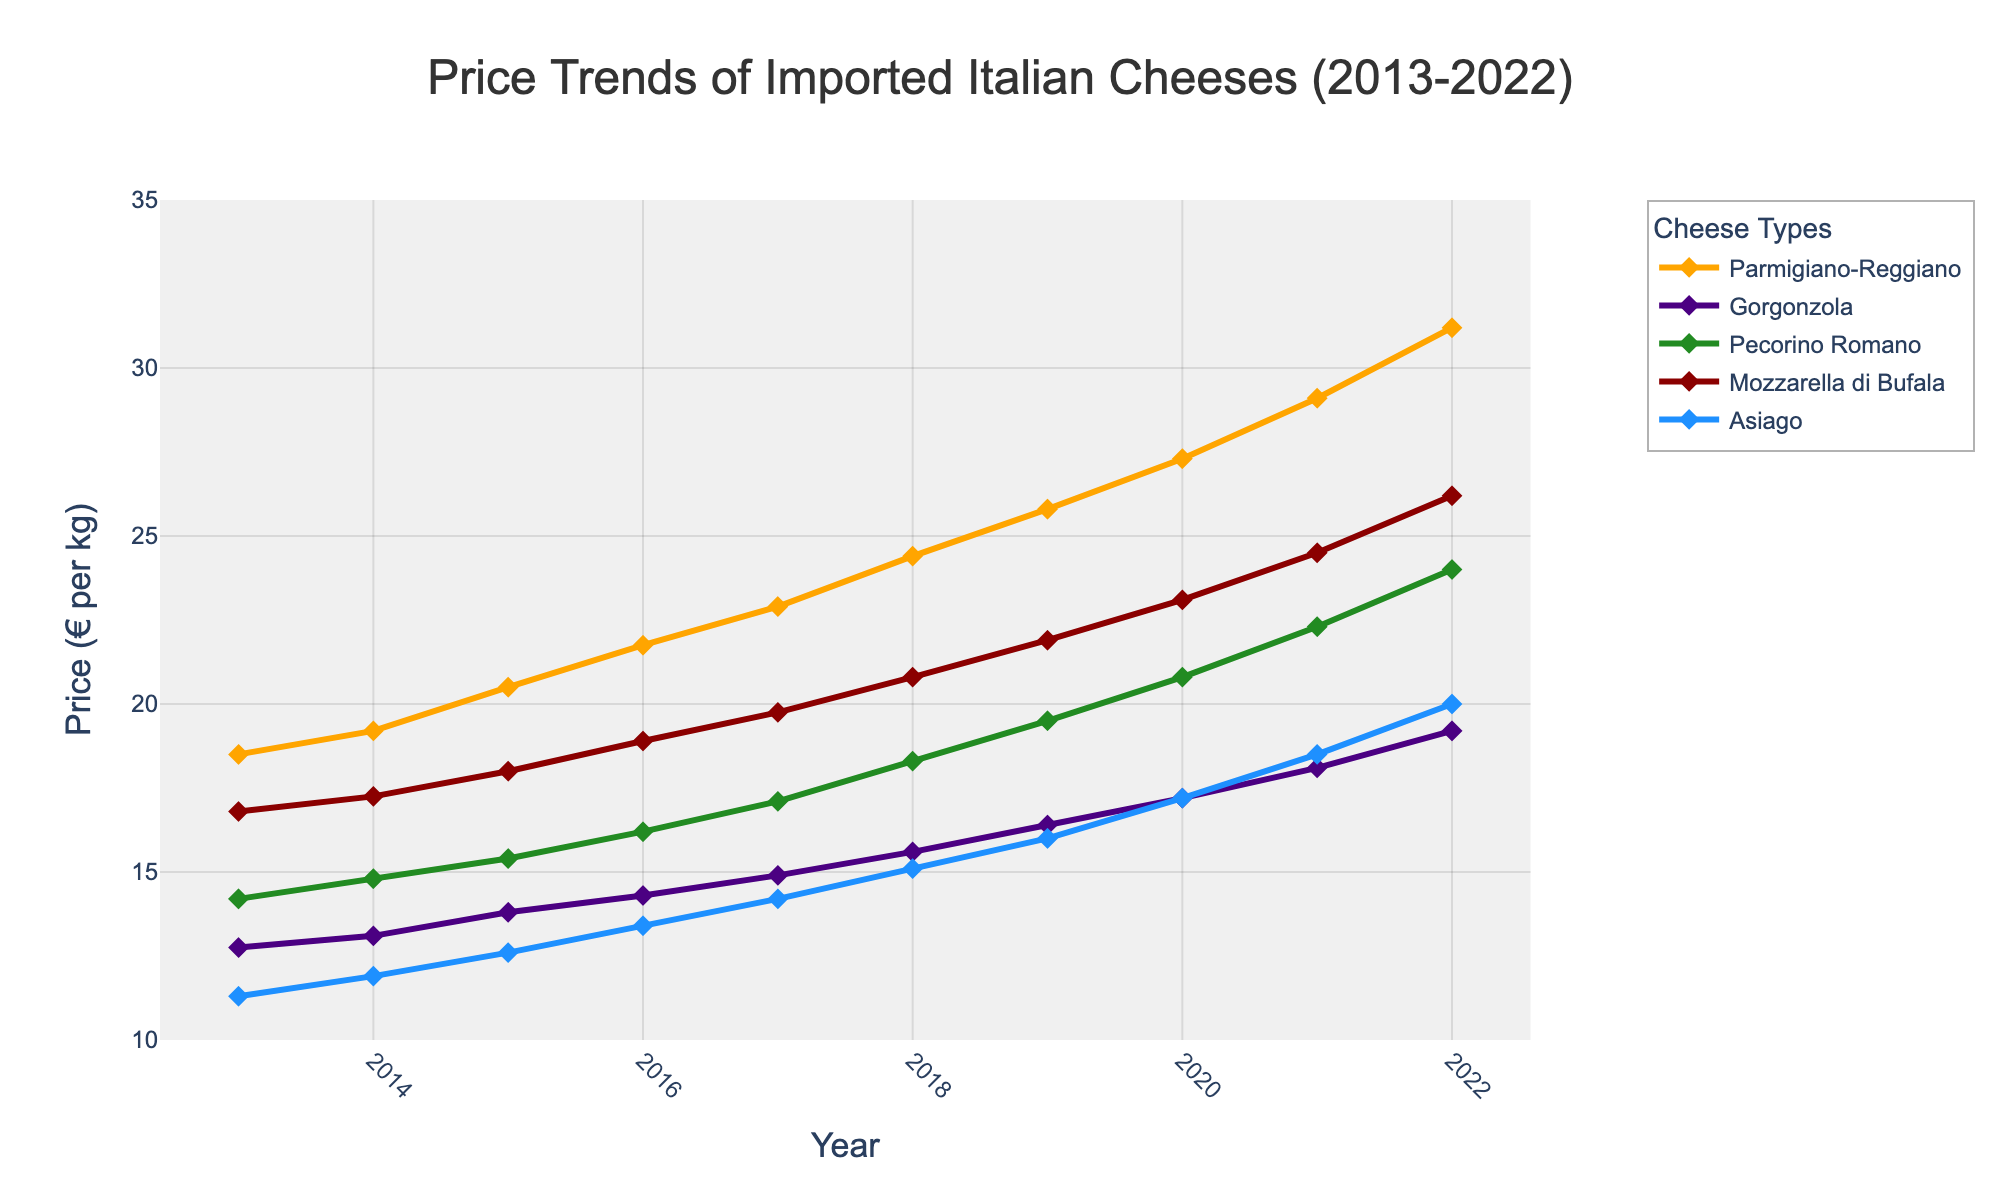What is the trend of Parmigiano-Reggiano prices from 2013 to 2022? The line for Parmigiano-Reggiano shows a consistent upward trend throughout the decade, starting at 18.50€ in 2013 and reaching 31.20€ in 2022.
Answer: Prices consistently increased Which cheese had the highest price in 2022, and what was it? By looking at the 2022 data points, Parmigiano-Reggiano had the highest price among the cheeses, with a price of 31.20€.
Answer: Parmigiano-Reggiano at 31.20€ How much did the price of Mozzarella di Bufala increase from 2013 to 2022? Subtract the 2013 price (16.80€) from the 2022 price (26.20€) to find the increase. 26.20€ - 16.80€ = 9.40€.
Answer: 9.40€ In which year did Gorgonzola prices experience the highest year-over-year increase? Compare the year-over-year differences for Gorgonzola: 
2013-2014: 0.35€, 2014-2015: 0.70€, 2015-2016: 0.50€, 2016-2017: 0.60€, 2017-2018: 0.70€, 2018-2019: 0.80€, 2019-2020: 0.80€, 2020-2021: 0.90€, 2021-2022: 1.10€. The largest increase was from 2021 to 2022.
Answer: 2021-2022 Which cheese had the lowest price in 2013, and what was it? By examining the 2013 data points, Asiago was the cheese with the lowest price, at 11.30€.
Answer: Asiago at 11.30€ What is the average price of Pecorino Romano over the entire period from 2013 to 2022? Sum the prices from 2013 to 2022 for Pecorino Romano and divide by the number of years (10). Sum = 14.20 + 14.80 + 15.40 + 16.20 + 17.10 + 18.30 + 19.50 + 20.80 + 22.30 + 24.00 = 182.60. Average = 182.60/10 = 18.26€
Answer: 18.26€ Compare the trends of Asiago and Gorgonzola prices over the decade. Which one showed a more significant increase percentage-wise? Calculate the percentage increase for both:
Asiago: (20.00€ - 11.30€) / 11.30€ * 100% ≈ 77%.
Gorgonzola: (19.20€ - 12.75€) / 12.75€ * 100% ≈ 50.59%.
Asiago had a more significant increase percentage-wise.
Answer: Asiago Between 2018 and 2020, which cheese had the smallest absolute price change? Calculate the absolute price changes:
Parmigiano-Reggiano: 27.30€ - 24.40€ = 2.90€
Gorgonzola: 17.20€ - 15.60€ = 1.60€
Pecorino Romano: 20.80€ - 18.30€ = 2.50€
Mozzarella di Bufala: 23.10€ - 20.80€ = 2.30€
Asiago: 17.20€ - 15.10€ = 2.10€
Gorgonzola had the smallest absolute change, 1.60€.
Answer: Gorgonzola with 1.60€ In 2020, how did the price of Mozzarella di Bufala compare to the price of Parmigiano-Reggiano in 2013? The price of Mozzarella di Bufala in 2020 (23.10€) was higher than the price of Parmigiano-Reggiano in 2013 (18.50€).
Answer: Mozzarella di Bufala was higher in 2020 Which cheese had the most consistent price increase without any decrease over the years? Inspecting the trends, Parmigiano-Reggiano's price consistently increased every year from 2013 to 2022 without any decrease.
Answer: Parmigiano-Reggiano 